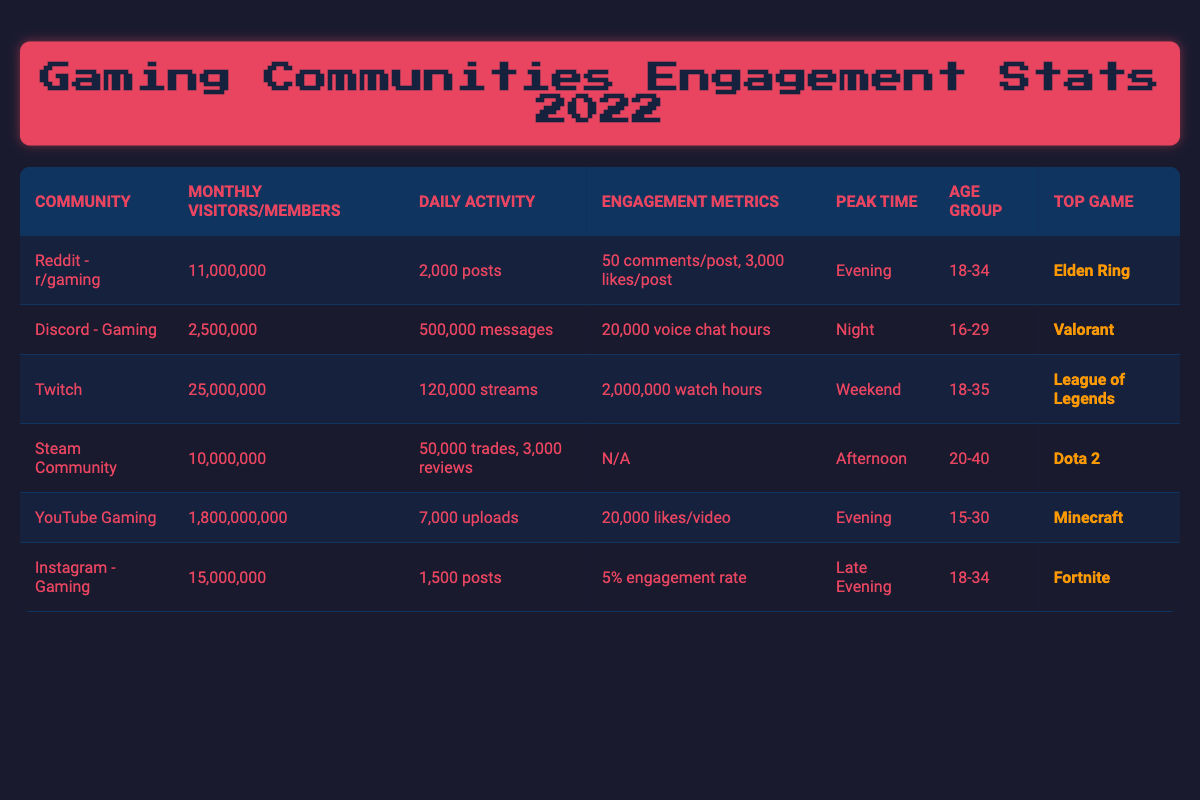What is the most popular game mentioned in the Reddit community? The table indicates that the most discussed game in the Reddit - r/gaming community is "Elden Ring."
Answer: Elden Ring Which gaming community has the highest average monthly visitors? The table shows that Twitch has 25,000,000 average monthly viewers, which is higher than any other community listed.
Answer: Twitch How many average daily posts does Instagram - Gaming have compared to Reddit - r/gaming? Instagram has 1,500 average daily posts, while Reddit has 2,000. Since 2,000 is greater than 1,500, Reddit posts more.
Answer: Reddit - r/gaming Is the dominant age group for Discord - Gaming younger than the dominant age group for Reddit - r/gaming? The dominant age group for Discord is 16-29, while for Reddit, it is 18-34. Since 16-29 is younger, the answer is yes.
Answer: Yes What is the engagement rate for Instagram - Gaming? The table lists the engagement rate for Instagram - Gaming as 0.05.
Answer: 0.05 How many average likes per video does YouTube Gaming receive compared to average likes per post in Reddit - r/gaming? YouTube Gaming receives 20,000 likes per video, while Reddit receives 3,000 likes per post. 20,000 is greater, indicating YouTube Gaming gets more likes.
Answer: YouTube Gaming receives more likes What is the total average monthly engagement for Steam Community's trades and reviews? For Steam Community, there are 50,000 average daily trades and 3,000 average daily reviews. Totaling these for one day gives 53,000. To find monthly, multiply by 30 (assuming 30 days): 53,000 × 30 = 1,590,000.
Answer: 1,590,000 How many more average weekly streams does Twitch have than the average daily messages in Discord? Twitch has 120,000 daily streams, which translates to 840,000 weekly streams (120,000 × 7). Discord has 500,000 daily messages, translating to 3,500,000 weekly messages (500,000 × 7). The difference is calculated as 3,500,000 - 840,000, which equals 2,660,000.
Answer: 2,660,000 Is the average number of daily messages in Discord higher than the average number of daily posts in Instagram - Gaming? Discord has 500,000 daily messages, while Instagram has 1,500 daily posts. Since 500,000 is greater than 1,500, the answer is yes.
Answer: Yes Which community has the largest user base, and how does it compare to the second largest? YouTube Gaming has 1,800,000,000 average monthly views, which is more than Twitch's 25,000,000 viewers, making it the largest by a significant margin.
Answer: YouTube Gaming has the largest user base 